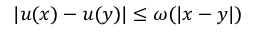Convert formula to latex. <formula><loc_0><loc_0><loc_500><loc_500>| u ( x ) - u ( y ) | \leq \omega ( | x - y | )</formula> 